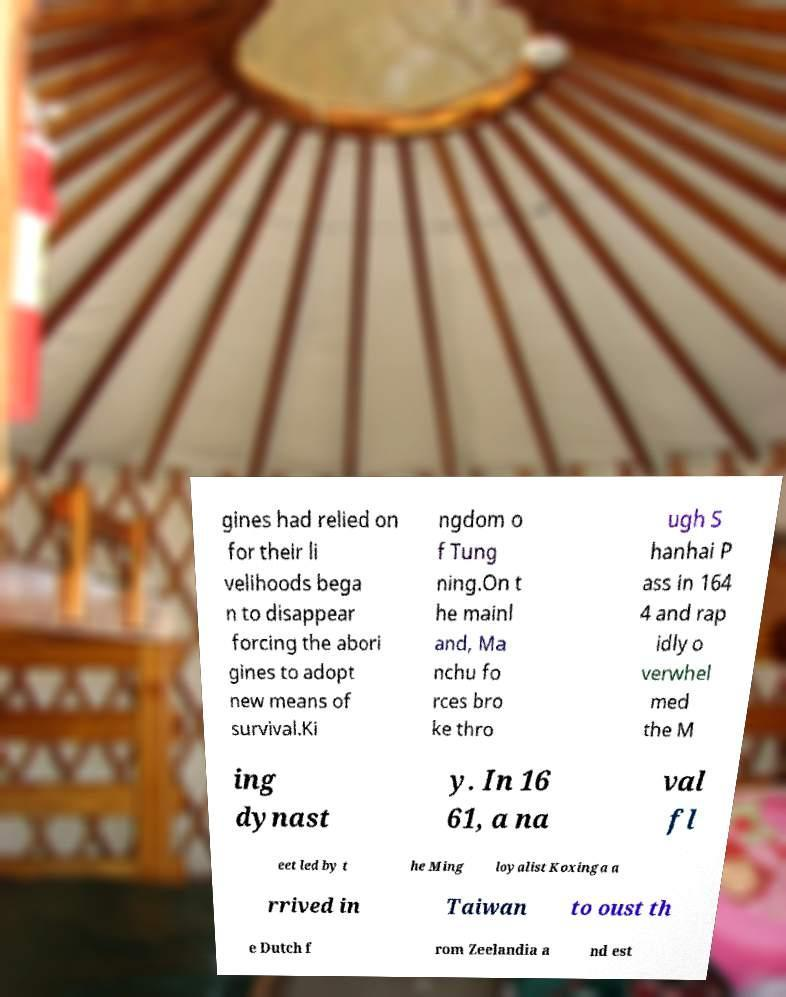Please read and relay the text visible in this image. What does it say? gines had relied on for their li velihoods bega n to disappear forcing the abori gines to adopt new means of survival.Ki ngdom o f Tung ning.On t he mainl and, Ma nchu fo rces bro ke thro ugh S hanhai P ass in 164 4 and rap idly o verwhel med the M ing dynast y. In 16 61, a na val fl eet led by t he Ming loyalist Koxinga a rrived in Taiwan to oust th e Dutch f rom Zeelandia a nd est 